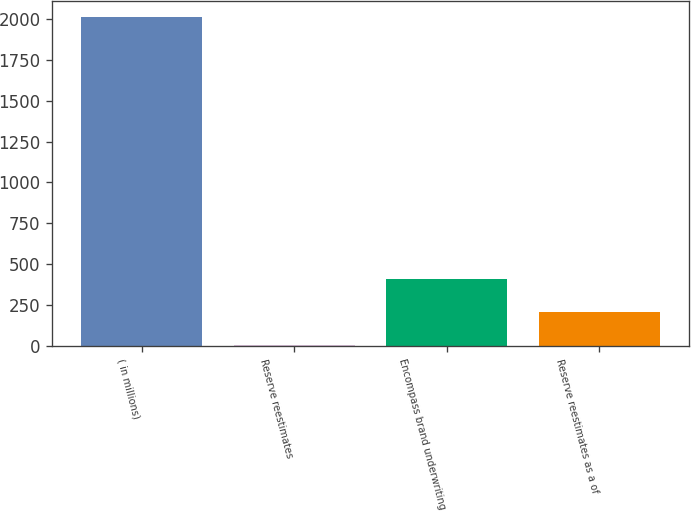<chart> <loc_0><loc_0><loc_500><loc_500><bar_chart><fcel>( in millions)<fcel>Reserve reestimates<fcel>Encompass brand underwriting<fcel>Reserve reestimates as a of<nl><fcel>2010<fcel>6<fcel>406.8<fcel>206.4<nl></chart> 